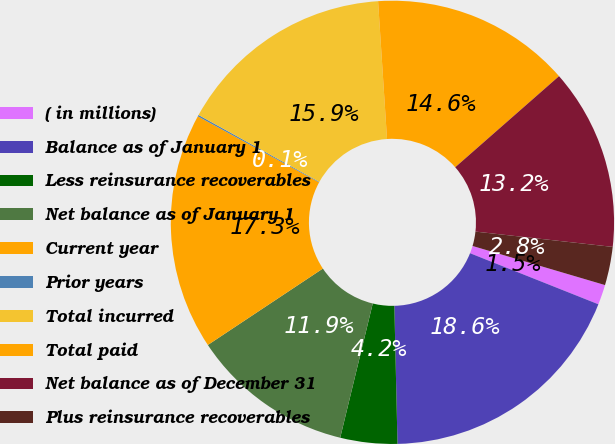Convert chart. <chart><loc_0><loc_0><loc_500><loc_500><pie_chart><fcel>( in millions)<fcel>Balance as of January 1<fcel>Less reinsurance recoverables<fcel>Net balance as of January 1<fcel>Current year<fcel>Prior years<fcel>Total incurred<fcel>Total paid<fcel>Net balance as of December 31<fcel>Plus reinsurance recoverables<nl><fcel>1.46%<fcel>18.61%<fcel>4.15%<fcel>11.88%<fcel>17.27%<fcel>0.11%<fcel>15.92%<fcel>14.57%<fcel>13.23%<fcel>2.8%<nl></chart> 